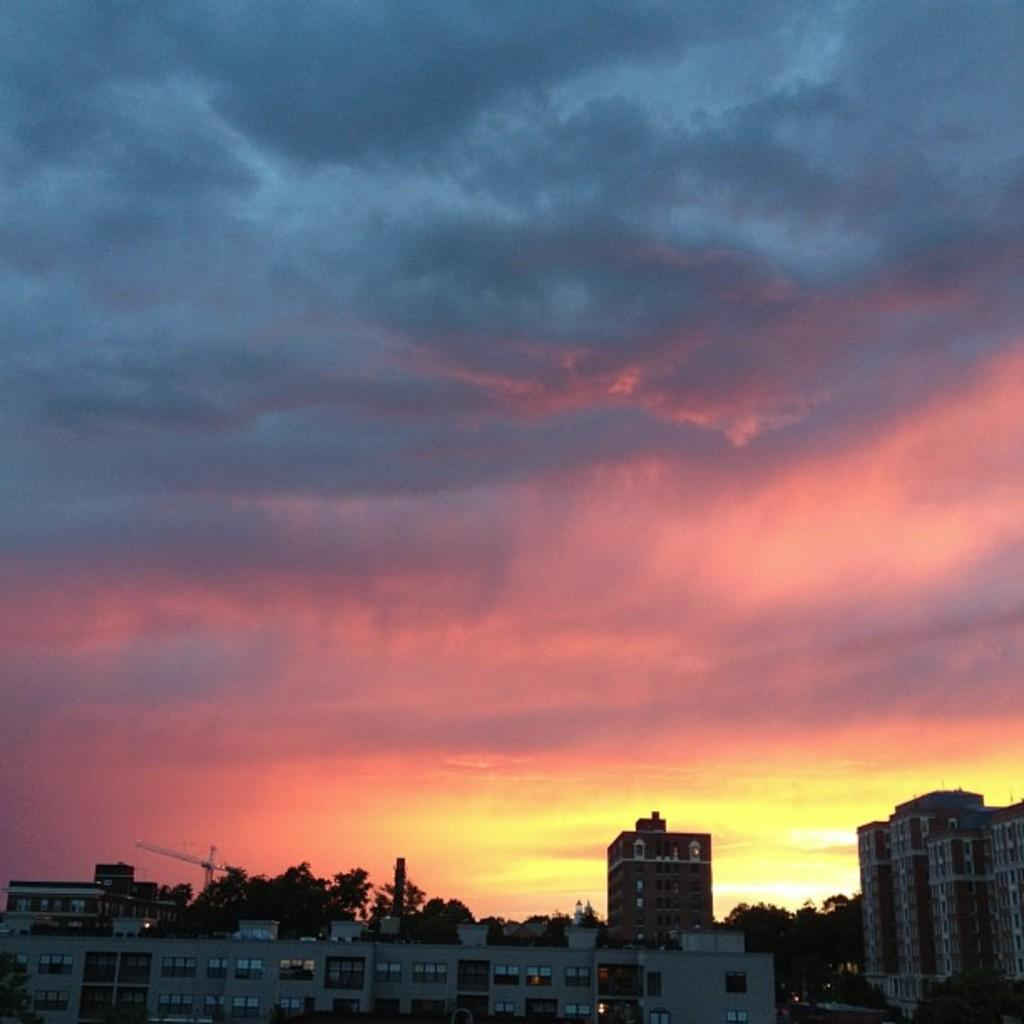What type of structures can be seen in the image? There are buildings in the image. What else is visible in the image besides the buildings? There are lights, a pole, an object that looks like an antenna, trees on the ground, and the sky in the background. Can you describe the pole in the image? The pole is a vertical structure that supports the object that looks like an antenna. What is the condition of the sky in the image? The sky is visible in the background of the image, and it is colorful. Where is the cup of pickles located in the image? There is no cup of pickles present in the image. What type of truck can be seen driving through the buildings in the image? There is no truck visible in the image; it only features buildings, lights, a pole, an object that looks like an antenna, trees on the ground, and the colorful sky in the background. 